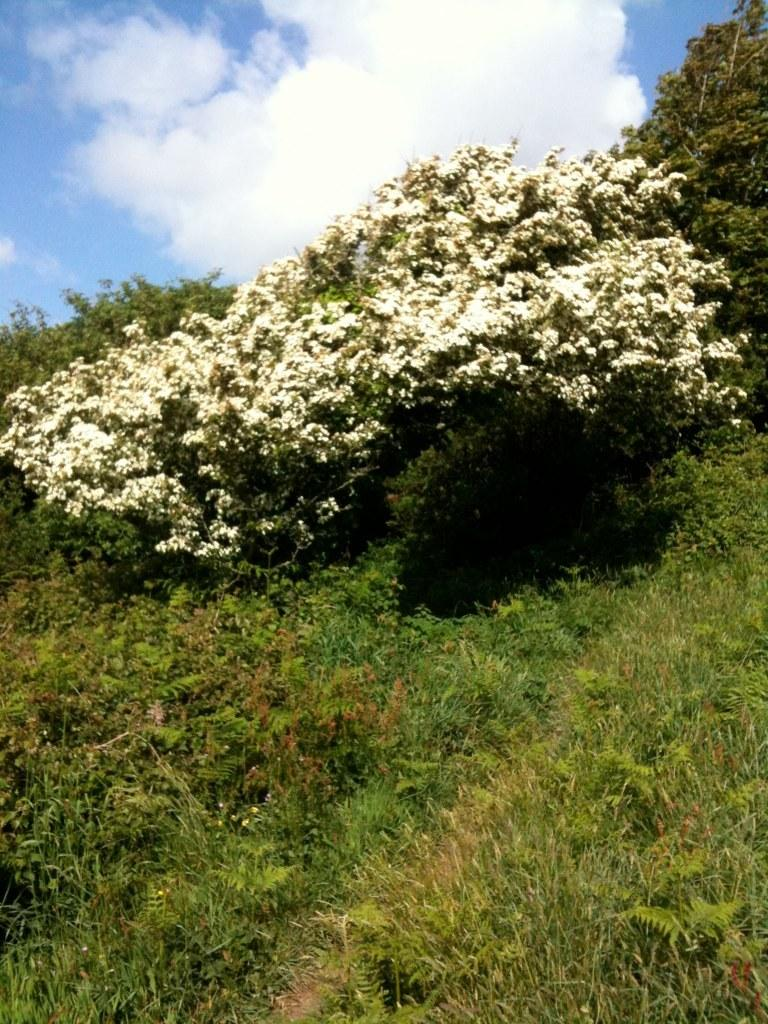What type of vegetation can be seen in the image? There is grass and plants in the image. What part of the natural environment is visible in the image? The sky is visible in the image. What can be seen in the sky in the image? Clouds are present in the sky. Can you see an airplane flying through the sky in the image? A: No, there is no airplane visible in the image; it only shows grass, plants, and clouds in the sky. 